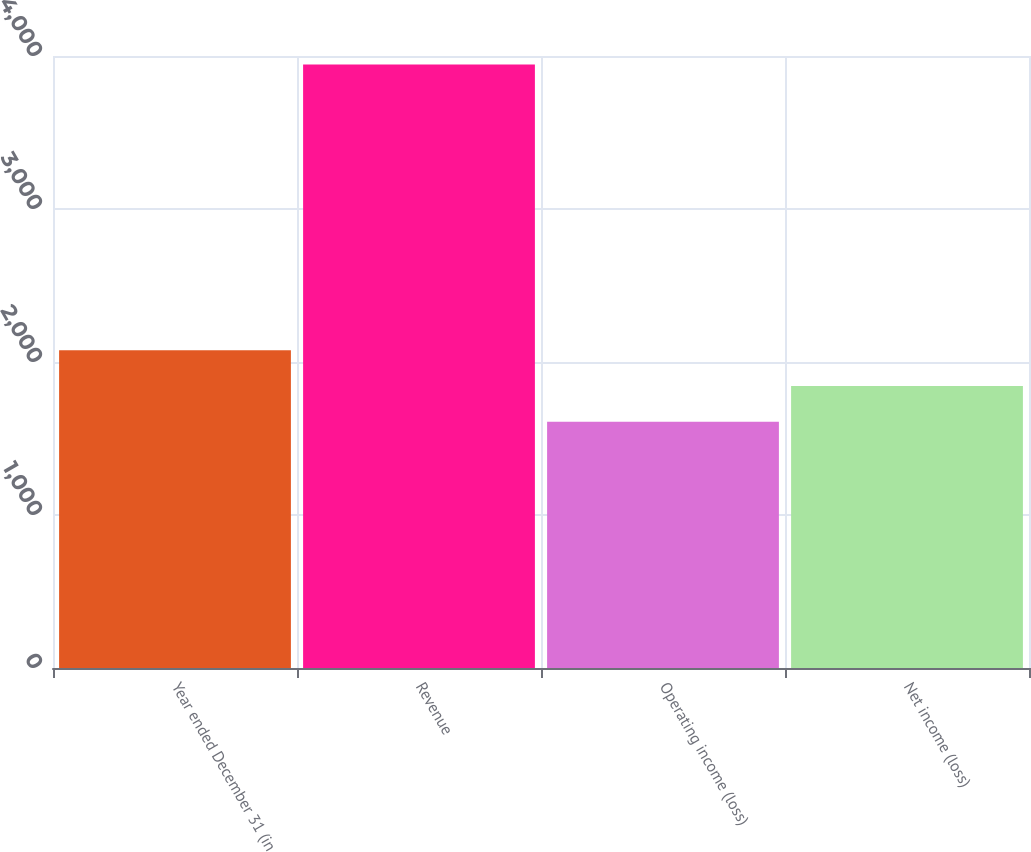<chart> <loc_0><loc_0><loc_500><loc_500><bar_chart><fcel>Year ended December 31 (in<fcel>Revenue<fcel>Operating income (loss)<fcel>Net income (loss)<nl><fcel>2076<fcel>3944<fcel>1609<fcel>1842.5<nl></chart> 